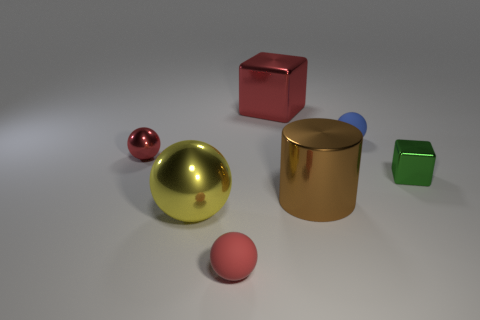What number of small blue things are the same shape as the big yellow object?
Keep it short and to the point. 1. There is a block that is behind the small metallic cube; is its color the same as the small matte sphere in front of the green object?
Your answer should be very brief. Yes. How many objects are green blocks or big red blocks?
Your answer should be very brief. 2. How many gray cylinders are the same material as the big brown thing?
Your answer should be very brief. 0. Is the number of blue things less than the number of tiny yellow metal balls?
Your answer should be very brief. No. Are the small red ball right of the large yellow metal object and the tiny green cube made of the same material?
Provide a succinct answer. No. How many cylinders are either rubber objects or green things?
Your answer should be compact. 0. What is the shape of the large shiny thing that is on the left side of the brown metal object and in front of the green shiny block?
Ensure brevity in your answer.  Sphere. There is a shiny cube that is in front of the red metal object in front of the big red metallic thing on the left side of the blue matte thing; what color is it?
Make the answer very short. Green. Is the number of small blue things on the right side of the tiny red metal object less than the number of metal things?
Offer a terse response. Yes. 